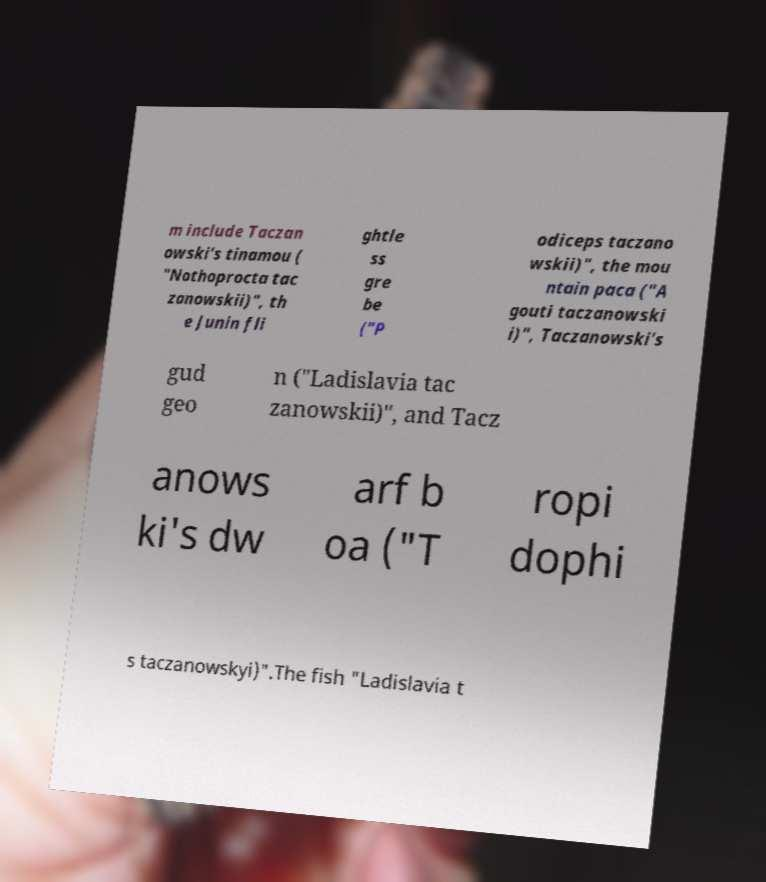There's text embedded in this image that I need extracted. Can you transcribe it verbatim? m include Taczan owski's tinamou ( "Nothoprocta tac zanowskii)", th e Junin fli ghtle ss gre be ("P odiceps taczano wskii)", the mou ntain paca ("A gouti taczanowski i)", Taczanowski's gud geo n ("Ladislavia tac zanowskii)", and Tacz anows ki's dw arf b oa ("T ropi dophi s taczanowskyi)".The fish "Ladislavia t 